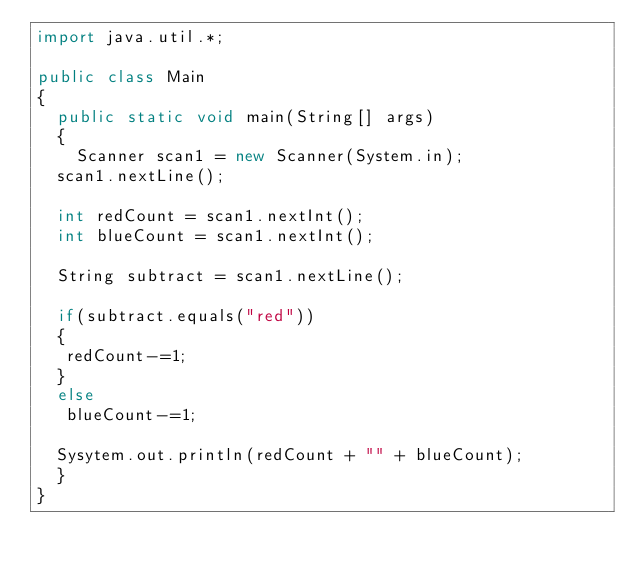Convert code to text. <code><loc_0><loc_0><loc_500><loc_500><_Java_>import java.util.*;
 
public class Main
{
  public static void main(String[] args)
  {
    Scanner scan1 = new Scanner(System.in);
	scan1.nextLine();
 
	int redCount = scan1.nextInt();
	int blueCount = scan1.nextInt();
 
	String subtract = scan1.nextLine();
 
	if(subtract.equals("red"))
	{
 	 redCount-=1;
	}
	else
 	 blueCount-=1;
 
	Sysytem.out.println(redCount + "" + blueCount);
  }
}</code> 